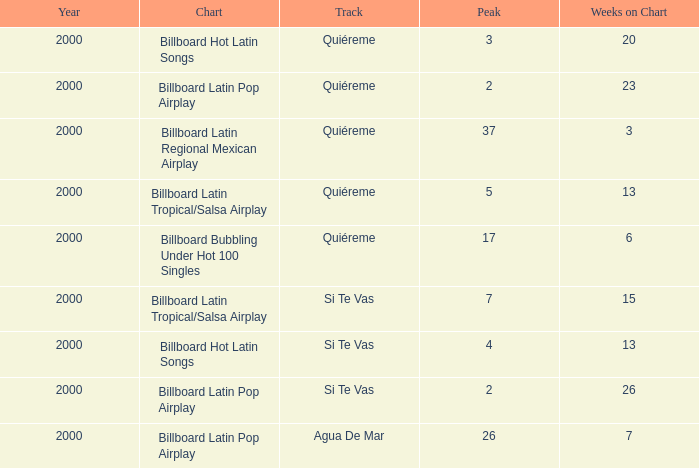Name the least weeks for year less than 2000 None. 